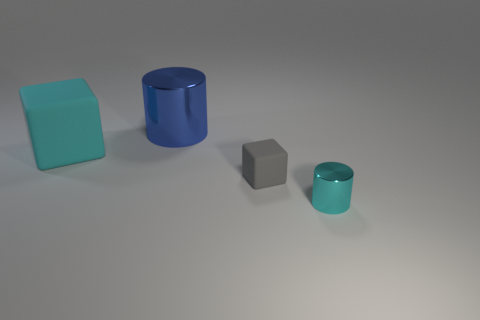Add 2 big cyan matte objects. How many objects exist? 6 Subtract 0 yellow cylinders. How many objects are left? 4 Subtract all large brown metal objects. Subtract all blue cylinders. How many objects are left? 3 Add 3 tiny gray rubber things. How many tiny gray rubber things are left? 4 Add 4 big yellow metallic objects. How many big yellow metallic objects exist? 4 